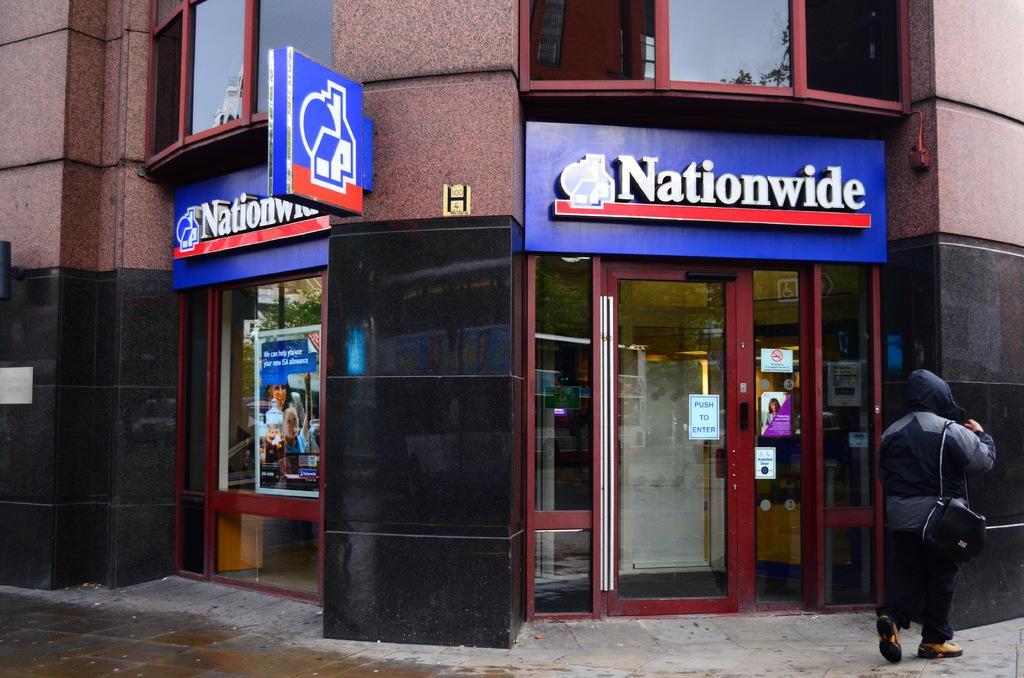How would you summarize this image in a sentence or two? A person is present on the right wearing a black dress and a black bag. There is a building at the back which has glass doors and there are posters attached on the doors. 